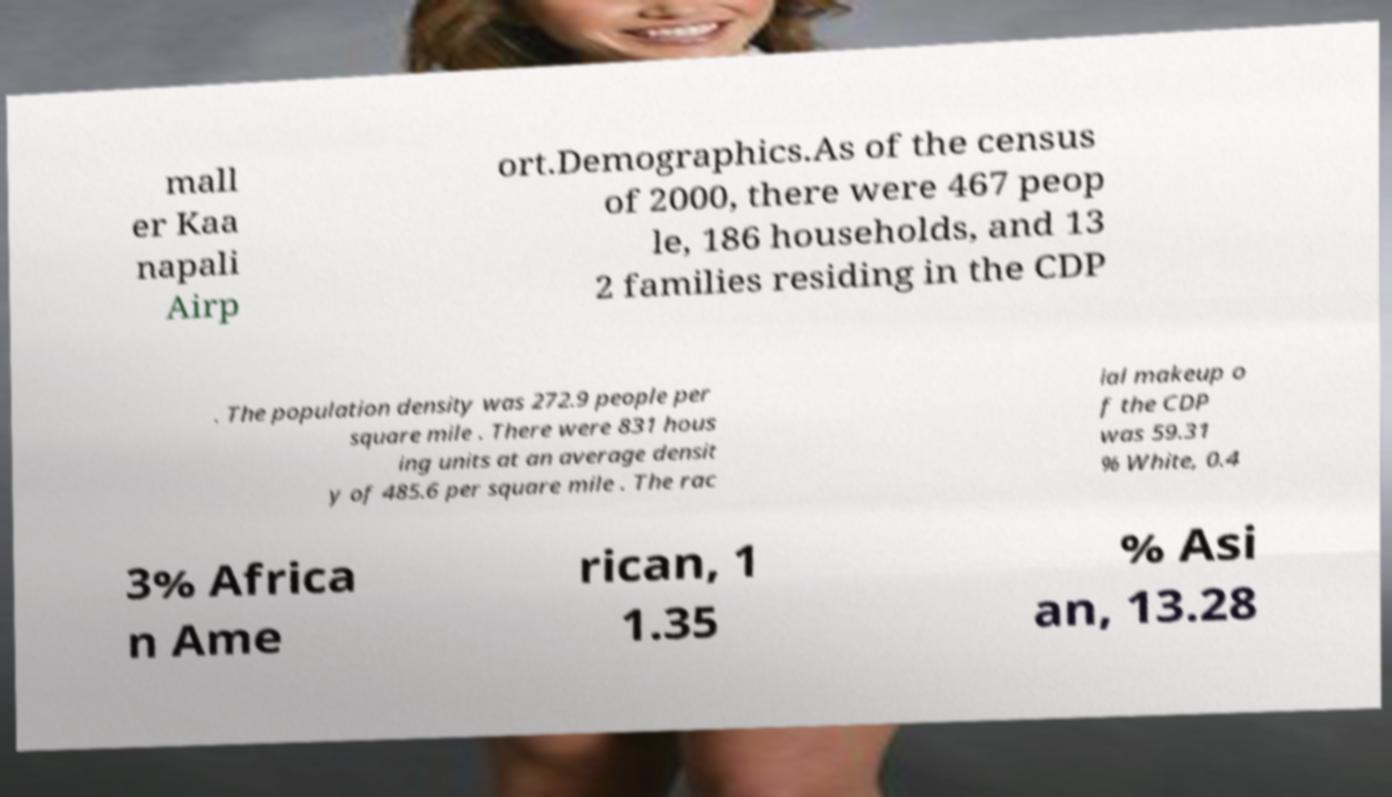Can you accurately transcribe the text from the provided image for me? mall er Kaa napali Airp ort.Demographics.As of the census of 2000, there were 467 peop le, 186 households, and 13 2 families residing in the CDP . The population density was 272.9 people per square mile . There were 831 hous ing units at an average densit y of 485.6 per square mile . The rac ial makeup o f the CDP was 59.31 % White, 0.4 3% Africa n Ame rican, 1 1.35 % Asi an, 13.28 